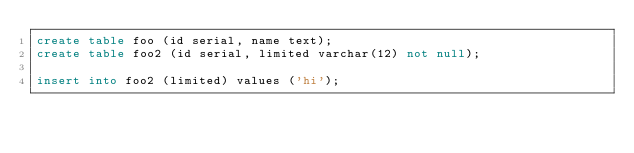<code> <loc_0><loc_0><loc_500><loc_500><_SQL_>create table foo (id serial, name text);
create table foo2 (id serial, limited varchar(12) not null);

insert into foo2 (limited) values ('hi');
</code> 